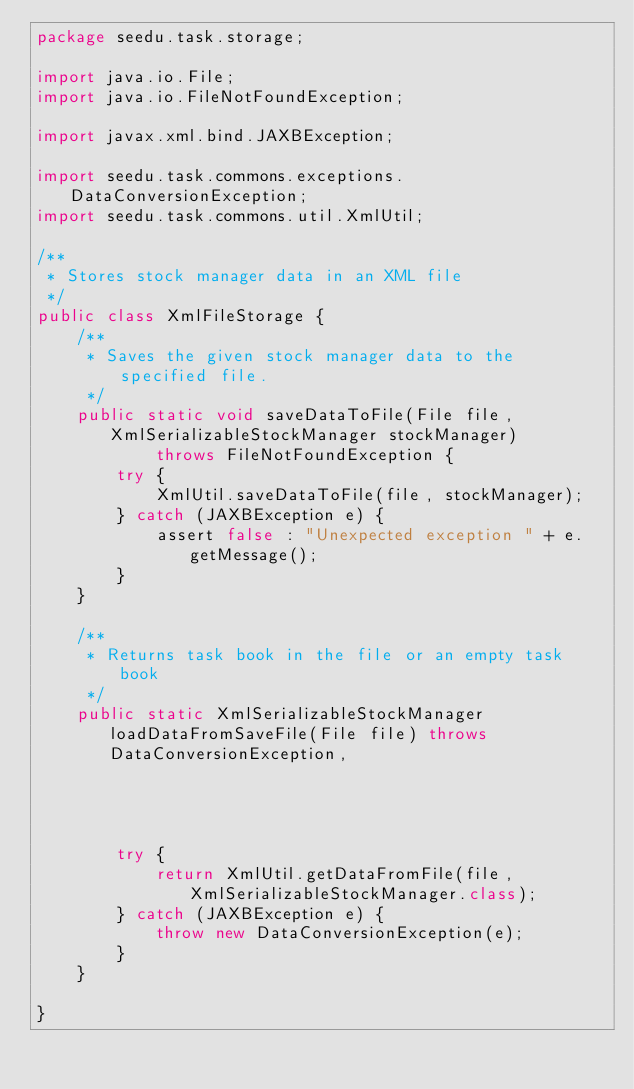Convert code to text. <code><loc_0><loc_0><loc_500><loc_500><_Java_>package seedu.task.storage;

import java.io.File;
import java.io.FileNotFoundException;

import javax.xml.bind.JAXBException;

import seedu.task.commons.exceptions.DataConversionException;
import seedu.task.commons.util.XmlUtil;

/**
 * Stores stock manager data in an XML file
 */
public class XmlFileStorage {
    /**
     * Saves the given stock manager data to the specified file.
     */
    public static void saveDataToFile(File file, XmlSerializableStockManager stockManager)
            throws FileNotFoundException {
        try {
            XmlUtil.saveDataToFile(file, stockManager);
        } catch (JAXBException e) {
            assert false : "Unexpected exception " + e.getMessage();
        }
    }

    /**
     * Returns task book in the file or an empty task book
     */
    public static XmlSerializableStockManager loadDataFromSaveFile(File file) throws DataConversionException,
                                                                            FileNotFoundException {
        try {
            return XmlUtil.getDataFromFile(file, XmlSerializableStockManager.class);
        } catch (JAXBException e) {
            throw new DataConversionException(e);
        }
    }

}
</code> 